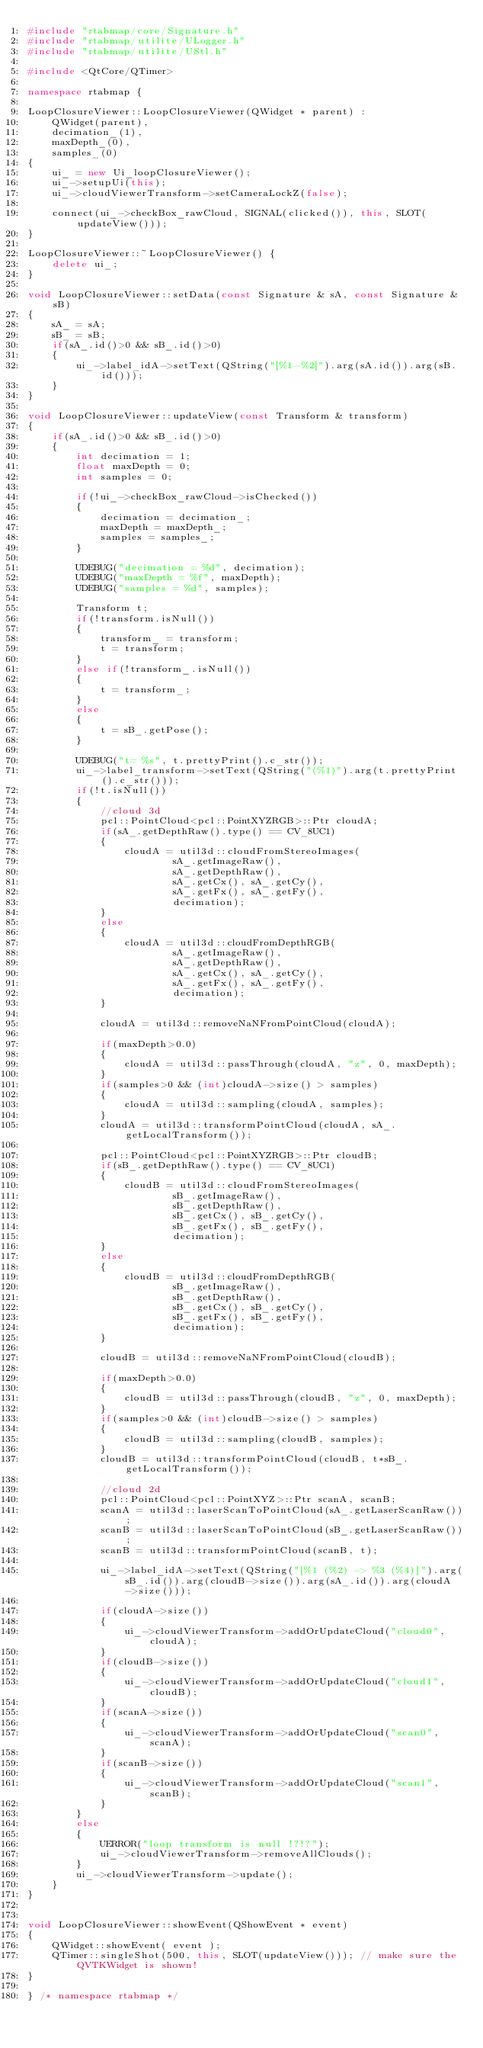<code> <loc_0><loc_0><loc_500><loc_500><_C++_>#include "rtabmap/core/Signature.h"
#include "rtabmap/utilite/ULogger.h"
#include "rtabmap/utilite/UStl.h"

#include <QtCore/QTimer>

namespace rtabmap {

LoopClosureViewer::LoopClosureViewer(QWidget * parent) :
	QWidget(parent),
	decimation_(1),
	maxDepth_(0),
	samples_(0)
{
	ui_ = new Ui_loopClosureViewer();
	ui_->setupUi(this);
	ui_->cloudViewerTransform->setCameraLockZ(false);

	connect(ui_->checkBox_rawCloud, SIGNAL(clicked()), this, SLOT(updateView()));
}

LoopClosureViewer::~LoopClosureViewer() {
	delete ui_;
}

void LoopClosureViewer::setData(const Signature & sA, const Signature & sB)
{
	sA_ = sA;
	sB_ = sB;
	if(sA_.id()>0 && sB_.id()>0)
	{
		ui_->label_idA->setText(QString("[%1-%2]").arg(sA.id()).arg(sB.id()));
	}
}

void LoopClosureViewer::updateView(const Transform & transform)
{
	if(sA_.id()>0 && sB_.id()>0)
	{
		int decimation = 1;
		float maxDepth = 0;
		int samples = 0;

		if(!ui_->checkBox_rawCloud->isChecked())
		{			decimation = decimation_;
			maxDepth = maxDepth_;
			samples = samples_;
		}

		UDEBUG("decimation = %d", decimation);
		UDEBUG("maxDepth = %f", maxDepth);
		UDEBUG("samples = %d", samples);

		Transform t;
		if(!transform.isNull())
		{
			transform_ = transform;
			t = transform;
		}
		else if(!transform_.isNull())
		{
			t = transform_;
		}
		else
		{
			t = sB_.getPose();
		}

		UDEBUG("t= %s", t.prettyPrint().c_str());
		ui_->label_transform->setText(QString("(%1)").arg(t.prettyPrint().c_str()));
		if(!t.isNull())
		{
			//cloud 3d
			pcl::PointCloud<pcl::PointXYZRGB>::Ptr cloudA;
			if(sA_.getDepthRaw().type() == CV_8UC1)
			{
				cloudA = util3d::cloudFromStereoImages(
						sA_.getImageRaw(),
						sA_.getDepthRaw(),
						sA_.getCx(), sA_.getCy(),
						sA_.getFx(), sA_.getFy(),
						decimation);
			}
			else
			{
				cloudA = util3d::cloudFromDepthRGB(
						sA_.getImageRaw(),
						sA_.getDepthRaw(),
						sA_.getCx(), sA_.getCy(),
						sA_.getFx(), sA_.getFy(),
						decimation);
			}

			cloudA = util3d::removeNaNFromPointCloud(cloudA);

			if(maxDepth>0.0)
			{
				cloudA = util3d::passThrough(cloudA, "z", 0, maxDepth);
			}
			if(samples>0 && (int)cloudA->size() > samples)
			{
				cloudA = util3d::sampling(cloudA, samples);
			}
			cloudA = util3d::transformPointCloud(cloudA, sA_.getLocalTransform());

			pcl::PointCloud<pcl::PointXYZRGB>::Ptr cloudB;
			if(sB_.getDepthRaw().type() == CV_8UC1)
			{
				cloudB = util3d::cloudFromStereoImages(
						sB_.getImageRaw(),
						sB_.getDepthRaw(),
						sB_.getCx(), sB_.getCy(),
						sB_.getFx(), sB_.getFy(),
						decimation);
			}
			else
			{
				cloudB = util3d::cloudFromDepthRGB(
						sB_.getImageRaw(),
						sB_.getDepthRaw(),
						sB_.getCx(), sB_.getCy(),
						sB_.getFx(), sB_.getFy(),
						decimation);
			}

			cloudB = util3d::removeNaNFromPointCloud(cloudB);

			if(maxDepth>0.0)
			{
				cloudB = util3d::passThrough(cloudB, "z", 0, maxDepth);
			}
			if(samples>0 && (int)cloudB->size() > samples)
			{
				cloudB = util3d::sampling(cloudB, samples);
			}
			cloudB = util3d::transformPointCloud(cloudB, t*sB_.getLocalTransform());

			//cloud 2d
			pcl::PointCloud<pcl::PointXYZ>::Ptr scanA, scanB;
			scanA = util3d::laserScanToPointCloud(sA_.getLaserScanRaw());
			scanB = util3d::laserScanToPointCloud(sB_.getLaserScanRaw());
			scanB = util3d::transformPointCloud(scanB, t);

			ui_->label_idA->setText(QString("[%1 (%2) -> %3 (%4)]").arg(sB_.id()).arg(cloudB->size()).arg(sA_.id()).arg(cloudA->size()));

			if(cloudA->size())
			{
				ui_->cloudViewerTransform->addOrUpdateCloud("cloud0", cloudA);
			}
			if(cloudB->size())
			{
				ui_->cloudViewerTransform->addOrUpdateCloud("cloud1", cloudB);
			}
			if(scanA->size())
			{
				ui_->cloudViewerTransform->addOrUpdateCloud("scan0", scanA);
			}
			if(scanB->size())
			{
				ui_->cloudViewerTransform->addOrUpdateCloud("scan1", scanB);
			}
		}
		else
		{
			UERROR("loop transform is null !?!?");
			ui_->cloudViewerTransform->removeAllClouds();
		}
		ui_->cloudViewerTransform->update();
	}
}


void LoopClosureViewer::showEvent(QShowEvent * event)
{
	QWidget::showEvent( event );
	QTimer::singleShot(500, this, SLOT(updateView())); // make sure the QVTKWidget is shown!
}

} /* namespace rtabmap */
</code> 